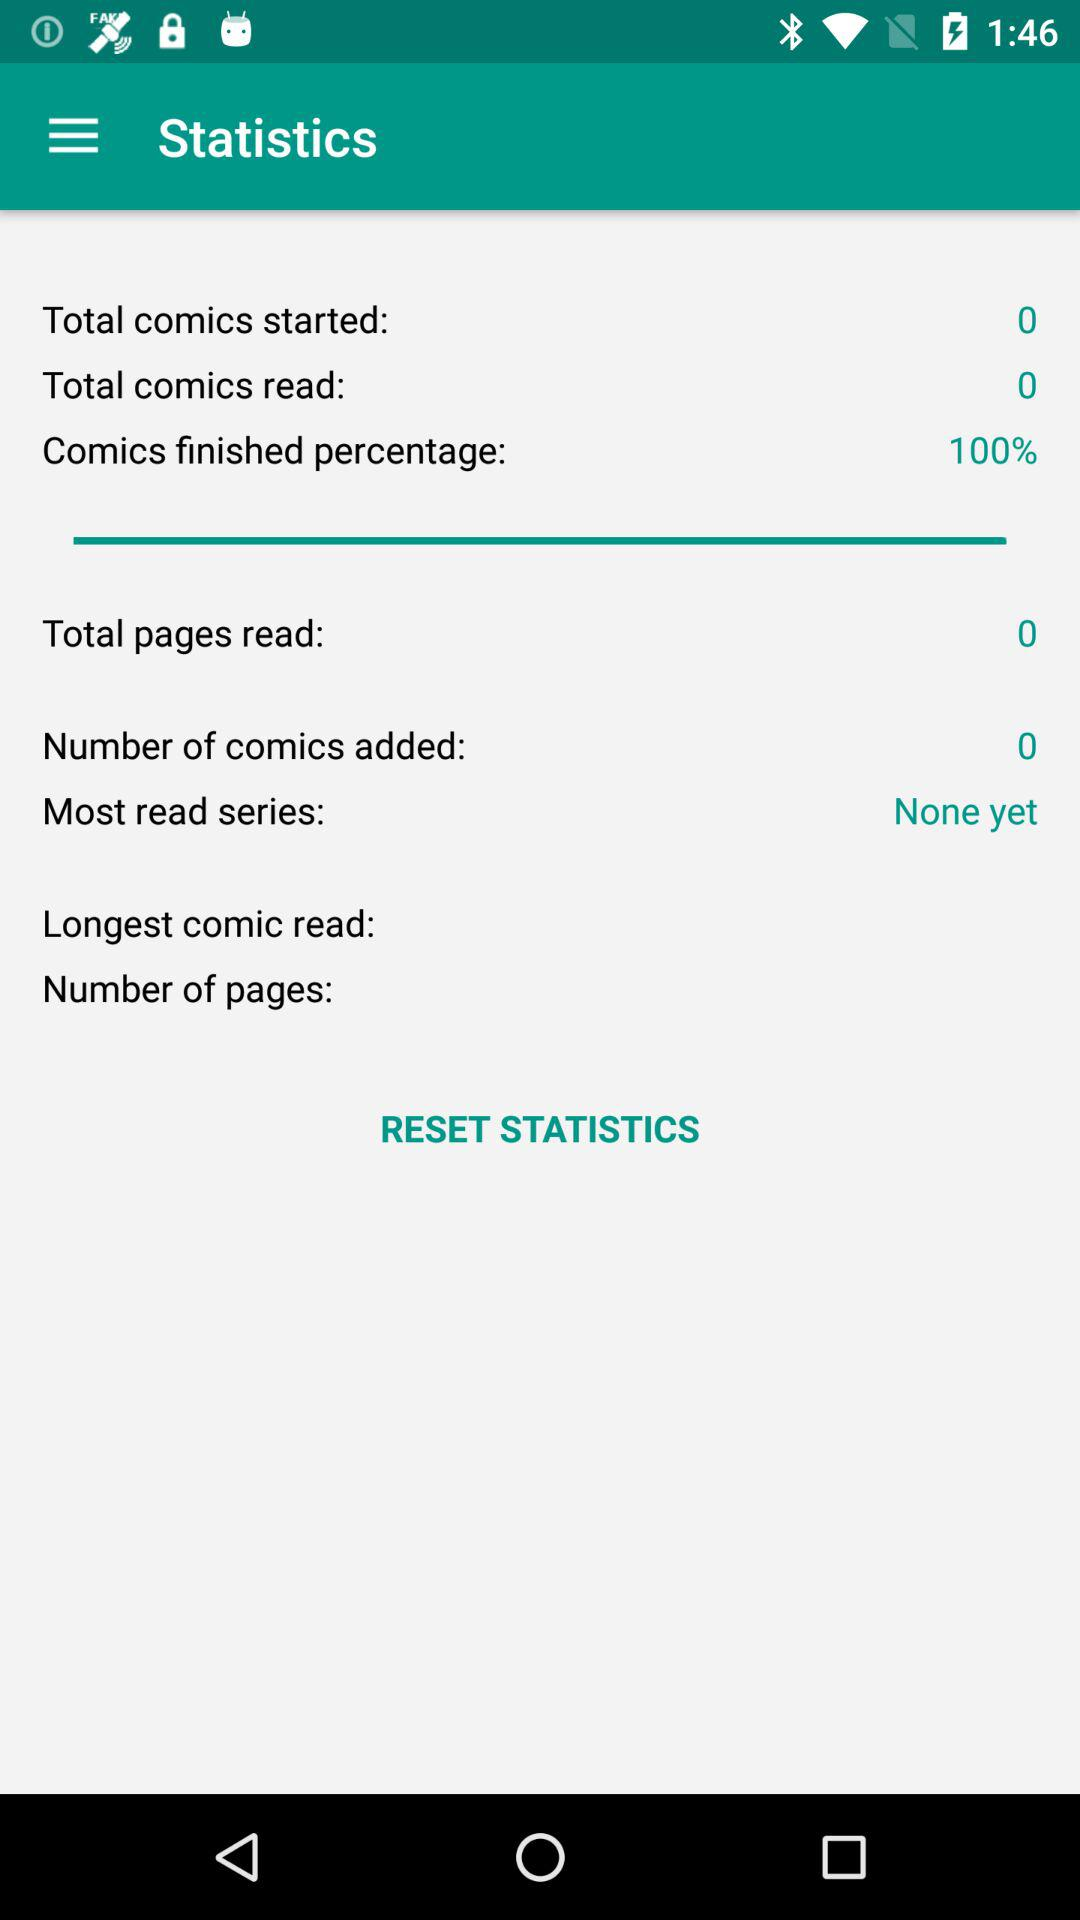What percentage of comics have I finished?
Answer the question using a single word or phrase. 100% 